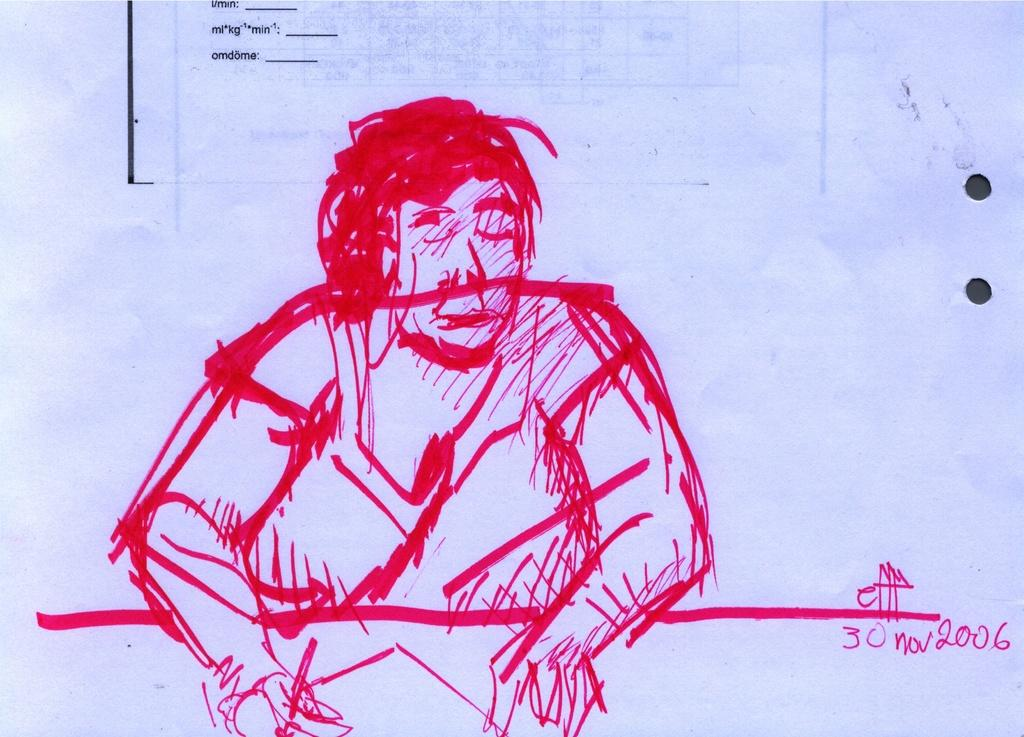What is depicted on the paper in the image? There is a drawing of a man on the paper. What else can be seen on the paper besides the drawing? There is text on the paper. What type of record is being played in the image? There is no record or any indication of music playing in the image; it only features a drawing of a man and text on the paper. 